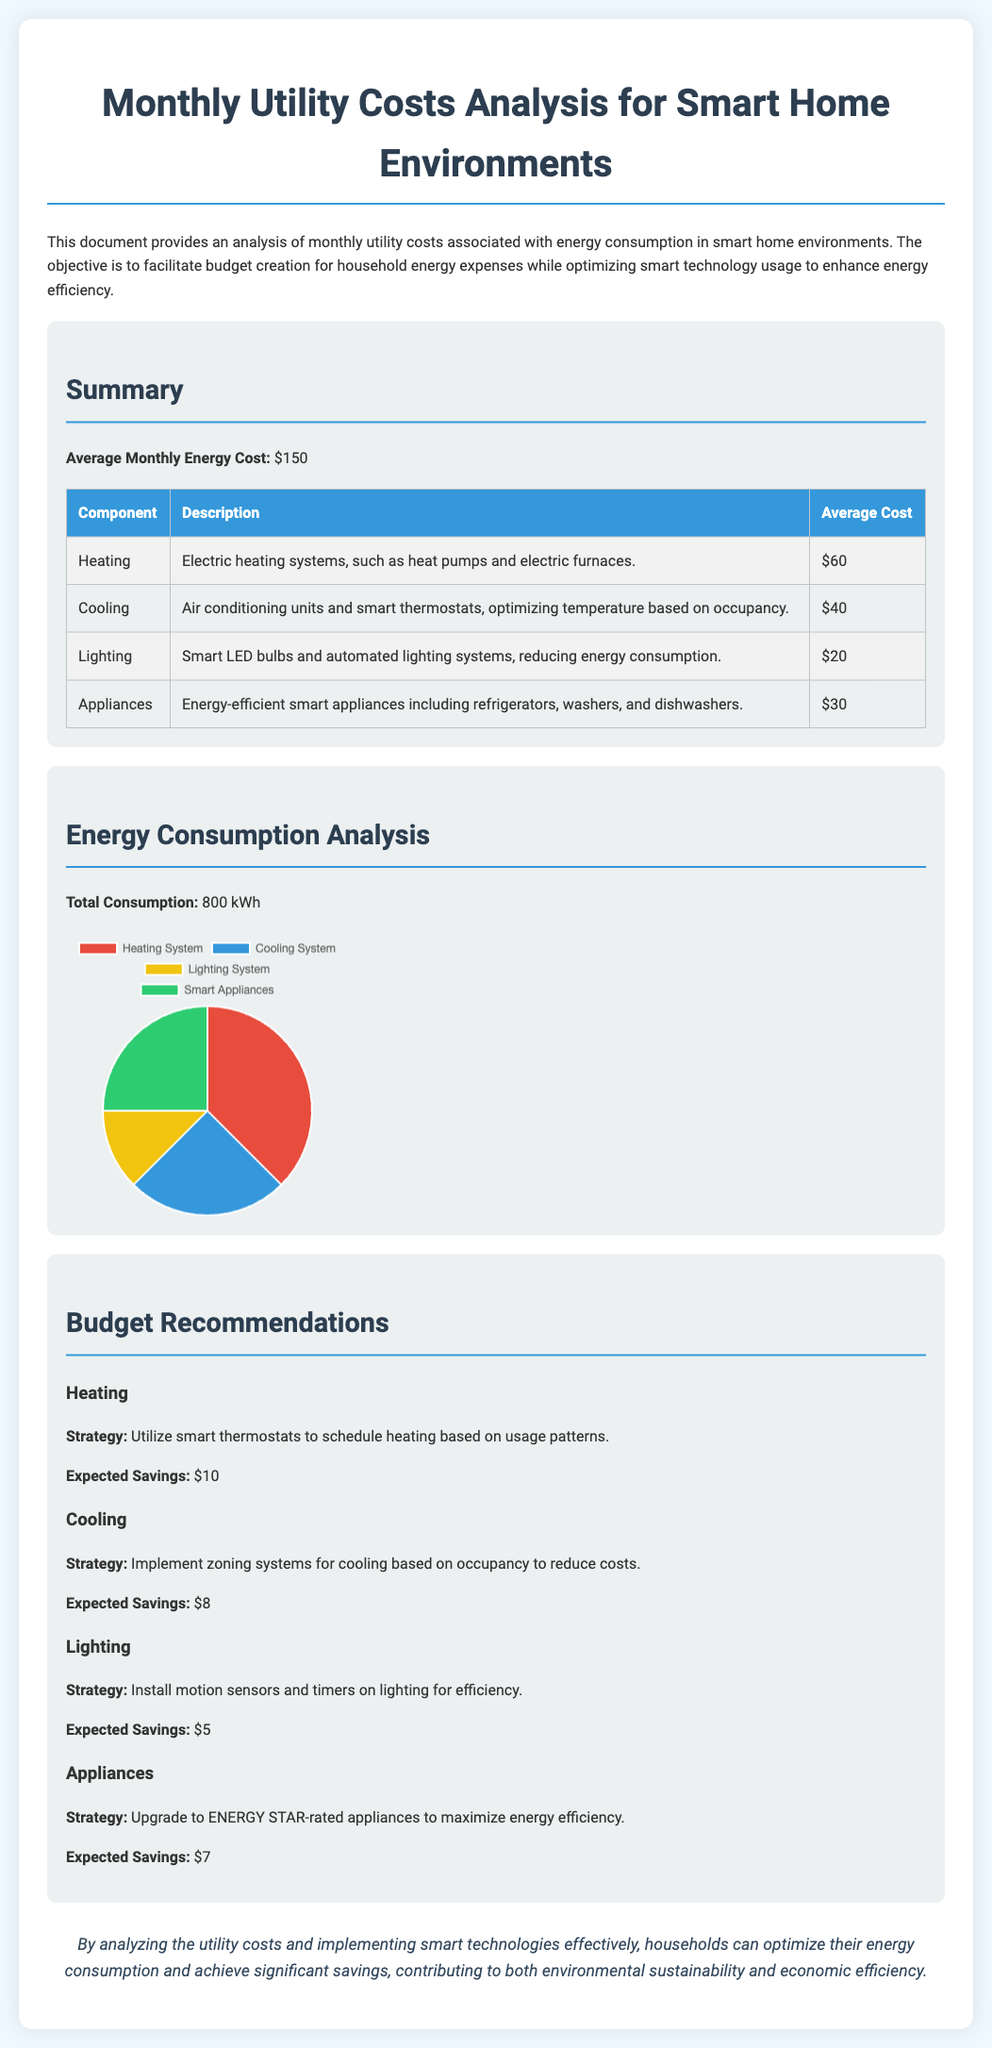What is the average monthly energy cost? The average monthly energy cost is stated in the summary section of the document.
Answer: $150 What is the total energy consumption? The total energy consumption is mentioned in the analysis section of the document.
Answer: 800 kWh How much does heating contribute to the average monthly cost? The average cost for heating is listed in the table under the summary section.
Answer: $60 What is the expected savings from upgrading appliances? The expected savings from upgrading appliances is provided under the budget recommendations section.
Answer: $7 What strategy is recommended for cooling? The recommended strategy for cooling is detailed in the budget recommendations under the cooling section.
Answer: Implement zoning systems for cooling based on occupancy to reduce costs What percentage of energy consumption is attributed to lighting? The percentage attributed to lighting is derived from the pie chart data in the document.
Answer: 12.5 What type of technology is suggested for lighting efficiency? The recommended technology for lighting efficiency is stated in the budget recommendations section.
Answer: Motion sensors and timers How much is allocated for cooling in the average monthly cost? The allocation for cooling is indicated in the summary table under average costs.
Answer: $40 